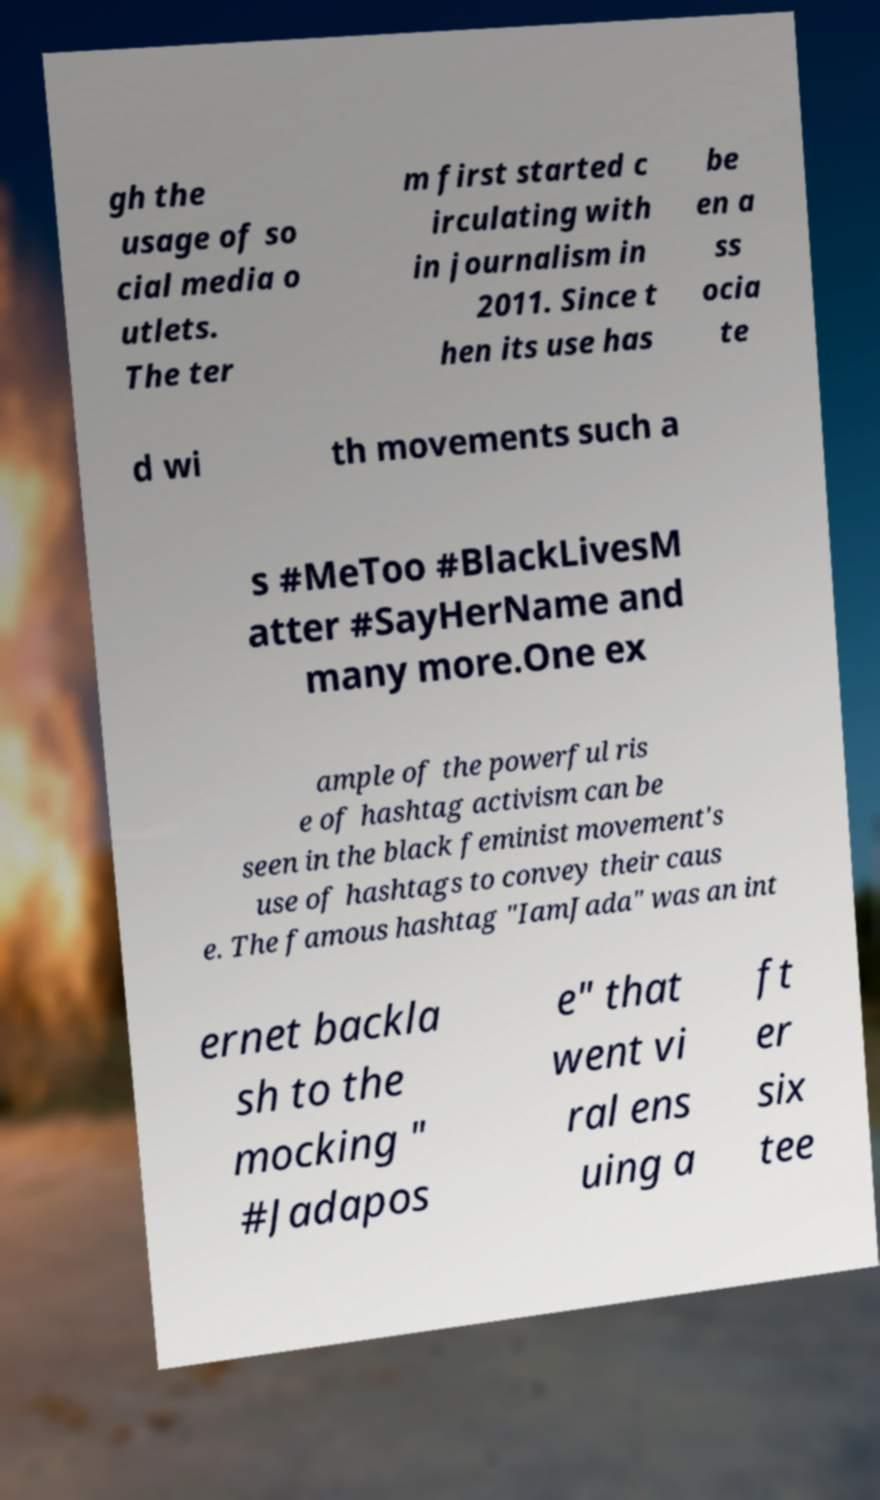Please read and relay the text visible in this image. What does it say? gh the usage of so cial media o utlets. The ter m first started c irculating with in journalism in 2011. Since t hen its use has be en a ss ocia te d wi th movements such a s #MeToo #BlackLivesM atter #SayHerName and many more.One ex ample of the powerful ris e of hashtag activism can be seen in the black feminist movement's use of hashtags to convey their caus e. The famous hashtag "IamJada" was an int ernet backla sh to the mocking " #Jadapos e" that went vi ral ens uing a ft er six tee 